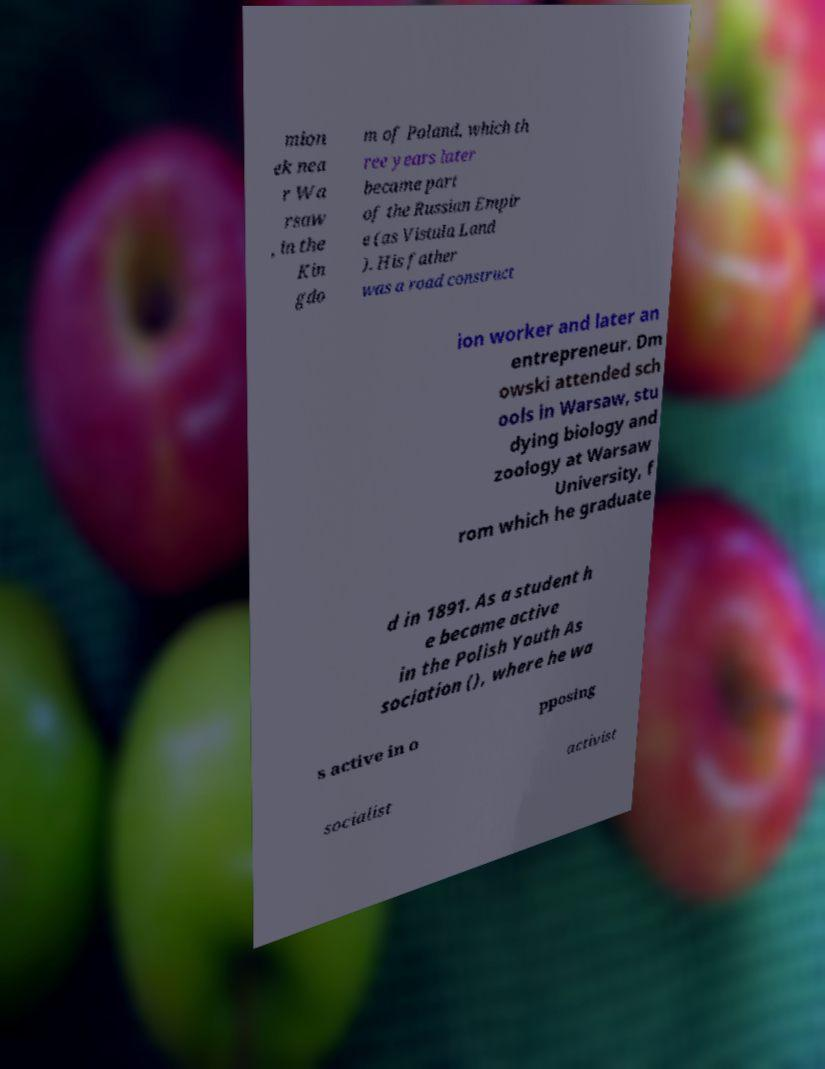Can you accurately transcribe the text from the provided image for me? mion ek nea r Wa rsaw , in the Kin gdo m of Poland, which th ree years later became part of the Russian Empir e (as Vistula Land ). His father was a road construct ion worker and later an entrepreneur. Dm owski attended sch ools in Warsaw, stu dying biology and zoology at Warsaw University, f rom which he graduate d in 1891. As a student h e became active in the Polish Youth As sociation (), where he wa s active in o pposing socialist activist 